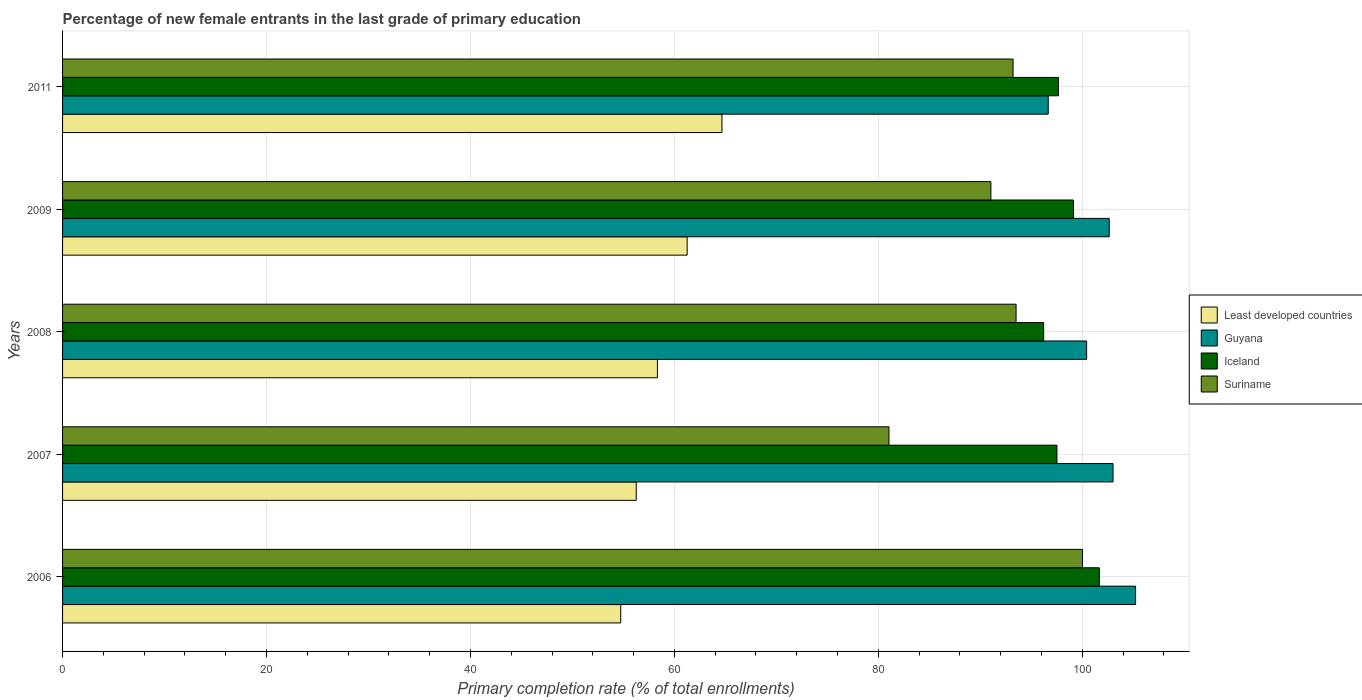How many different coloured bars are there?
Ensure brevity in your answer.  4. How many groups of bars are there?
Your response must be concise. 5. Are the number of bars on each tick of the Y-axis equal?
Make the answer very short. Yes. How many bars are there on the 2nd tick from the top?
Your answer should be compact. 4. How many bars are there on the 4th tick from the bottom?
Keep it short and to the point. 4. What is the label of the 3rd group of bars from the top?
Your response must be concise. 2008. What is the percentage of new female entrants in Suriname in 2007?
Make the answer very short. 81.04. Across all years, what is the maximum percentage of new female entrants in Suriname?
Your answer should be compact. 100.02. Across all years, what is the minimum percentage of new female entrants in Suriname?
Provide a succinct answer. 81.04. In which year was the percentage of new female entrants in Guyana maximum?
Your answer should be compact. 2006. In which year was the percentage of new female entrants in Guyana minimum?
Your response must be concise. 2011. What is the total percentage of new female entrants in Suriname in the graph?
Provide a short and direct response. 458.82. What is the difference between the percentage of new female entrants in Guyana in 2008 and that in 2009?
Your answer should be very brief. -2.21. What is the difference between the percentage of new female entrants in Suriname in 2011 and the percentage of new female entrants in Iceland in 2007?
Your answer should be compact. -4.3. What is the average percentage of new female entrants in Iceland per year?
Offer a terse response. 98.44. In the year 2007, what is the difference between the percentage of new female entrants in Iceland and percentage of new female entrants in Least developed countries?
Offer a very short reply. 41.26. In how many years, is the percentage of new female entrants in Suriname greater than 8 %?
Ensure brevity in your answer.  5. What is the ratio of the percentage of new female entrants in Iceland in 2009 to that in 2011?
Keep it short and to the point. 1.02. Is the percentage of new female entrants in Guyana in 2007 less than that in 2009?
Your answer should be compact. No. Is the difference between the percentage of new female entrants in Iceland in 2006 and 2008 greater than the difference between the percentage of new female entrants in Least developed countries in 2006 and 2008?
Give a very brief answer. Yes. What is the difference between the highest and the second highest percentage of new female entrants in Least developed countries?
Provide a short and direct response. 3.41. What is the difference between the highest and the lowest percentage of new female entrants in Guyana?
Provide a short and direct response. 8.57. Is it the case that in every year, the sum of the percentage of new female entrants in Least developed countries and percentage of new female entrants in Suriname is greater than the sum of percentage of new female entrants in Guyana and percentage of new female entrants in Iceland?
Make the answer very short. Yes. What does the 4th bar from the top in 2006 represents?
Offer a terse response. Least developed countries. What does the 3rd bar from the bottom in 2011 represents?
Provide a succinct answer. Iceland. Is it the case that in every year, the sum of the percentage of new female entrants in Least developed countries and percentage of new female entrants in Iceland is greater than the percentage of new female entrants in Guyana?
Give a very brief answer. Yes. How many bars are there?
Provide a succinct answer. 20. Are all the bars in the graph horizontal?
Your answer should be very brief. Yes. Are the values on the major ticks of X-axis written in scientific E-notation?
Offer a terse response. No. Does the graph contain any zero values?
Keep it short and to the point. No. How are the legend labels stacked?
Provide a short and direct response. Vertical. What is the title of the graph?
Your answer should be very brief. Percentage of new female entrants in the last grade of primary education. What is the label or title of the X-axis?
Give a very brief answer. Primary completion rate (% of total enrollments). What is the Primary completion rate (% of total enrollments) of Least developed countries in 2006?
Ensure brevity in your answer.  54.74. What is the Primary completion rate (% of total enrollments) in Guyana in 2006?
Your answer should be compact. 105.23. What is the Primary completion rate (% of total enrollments) of Iceland in 2006?
Offer a terse response. 101.67. What is the Primary completion rate (% of total enrollments) in Suriname in 2006?
Provide a succinct answer. 100.02. What is the Primary completion rate (% of total enrollments) in Least developed countries in 2007?
Your answer should be compact. 56.26. What is the Primary completion rate (% of total enrollments) in Guyana in 2007?
Offer a very short reply. 103.02. What is the Primary completion rate (% of total enrollments) of Iceland in 2007?
Keep it short and to the point. 97.52. What is the Primary completion rate (% of total enrollments) in Suriname in 2007?
Provide a short and direct response. 81.04. What is the Primary completion rate (% of total enrollments) of Least developed countries in 2008?
Your answer should be very brief. 58.34. What is the Primary completion rate (% of total enrollments) of Guyana in 2008?
Give a very brief answer. 100.43. What is the Primary completion rate (% of total enrollments) of Iceland in 2008?
Offer a very short reply. 96.21. What is the Primary completion rate (% of total enrollments) in Suriname in 2008?
Your response must be concise. 93.51. What is the Primary completion rate (% of total enrollments) of Least developed countries in 2009?
Provide a succinct answer. 61.25. What is the Primary completion rate (% of total enrollments) of Guyana in 2009?
Give a very brief answer. 102.64. What is the Primary completion rate (% of total enrollments) in Iceland in 2009?
Make the answer very short. 99.13. What is the Primary completion rate (% of total enrollments) of Suriname in 2009?
Provide a short and direct response. 91.04. What is the Primary completion rate (% of total enrollments) of Least developed countries in 2011?
Keep it short and to the point. 64.67. What is the Primary completion rate (% of total enrollments) in Guyana in 2011?
Provide a short and direct response. 96.66. What is the Primary completion rate (% of total enrollments) of Iceland in 2011?
Provide a succinct answer. 97.66. What is the Primary completion rate (% of total enrollments) in Suriname in 2011?
Keep it short and to the point. 93.21. Across all years, what is the maximum Primary completion rate (% of total enrollments) of Least developed countries?
Provide a short and direct response. 64.67. Across all years, what is the maximum Primary completion rate (% of total enrollments) of Guyana?
Offer a terse response. 105.23. Across all years, what is the maximum Primary completion rate (% of total enrollments) in Iceland?
Offer a terse response. 101.67. Across all years, what is the maximum Primary completion rate (% of total enrollments) in Suriname?
Provide a short and direct response. 100.02. Across all years, what is the minimum Primary completion rate (% of total enrollments) of Least developed countries?
Make the answer very short. 54.74. Across all years, what is the minimum Primary completion rate (% of total enrollments) in Guyana?
Ensure brevity in your answer.  96.66. Across all years, what is the minimum Primary completion rate (% of total enrollments) of Iceland?
Provide a short and direct response. 96.21. Across all years, what is the minimum Primary completion rate (% of total enrollments) of Suriname?
Offer a terse response. 81.04. What is the total Primary completion rate (% of total enrollments) in Least developed countries in the graph?
Provide a succinct answer. 295.25. What is the total Primary completion rate (% of total enrollments) in Guyana in the graph?
Give a very brief answer. 507.98. What is the total Primary completion rate (% of total enrollments) in Iceland in the graph?
Ensure brevity in your answer.  492.19. What is the total Primary completion rate (% of total enrollments) of Suriname in the graph?
Give a very brief answer. 458.82. What is the difference between the Primary completion rate (% of total enrollments) of Least developed countries in 2006 and that in 2007?
Your answer should be compact. -1.52. What is the difference between the Primary completion rate (% of total enrollments) of Guyana in 2006 and that in 2007?
Give a very brief answer. 2.21. What is the difference between the Primary completion rate (% of total enrollments) in Iceland in 2006 and that in 2007?
Make the answer very short. 4.16. What is the difference between the Primary completion rate (% of total enrollments) in Suriname in 2006 and that in 2007?
Your answer should be compact. 18.98. What is the difference between the Primary completion rate (% of total enrollments) of Least developed countries in 2006 and that in 2008?
Offer a terse response. -3.6. What is the difference between the Primary completion rate (% of total enrollments) in Guyana in 2006 and that in 2008?
Your response must be concise. 4.8. What is the difference between the Primary completion rate (% of total enrollments) of Iceland in 2006 and that in 2008?
Keep it short and to the point. 5.46. What is the difference between the Primary completion rate (% of total enrollments) in Suriname in 2006 and that in 2008?
Make the answer very short. 6.52. What is the difference between the Primary completion rate (% of total enrollments) of Least developed countries in 2006 and that in 2009?
Ensure brevity in your answer.  -6.51. What is the difference between the Primary completion rate (% of total enrollments) in Guyana in 2006 and that in 2009?
Ensure brevity in your answer.  2.59. What is the difference between the Primary completion rate (% of total enrollments) of Iceland in 2006 and that in 2009?
Offer a very short reply. 2.54. What is the difference between the Primary completion rate (% of total enrollments) of Suriname in 2006 and that in 2009?
Offer a very short reply. 8.98. What is the difference between the Primary completion rate (% of total enrollments) of Least developed countries in 2006 and that in 2011?
Offer a terse response. -9.93. What is the difference between the Primary completion rate (% of total enrollments) of Guyana in 2006 and that in 2011?
Your answer should be compact. 8.57. What is the difference between the Primary completion rate (% of total enrollments) of Iceland in 2006 and that in 2011?
Offer a terse response. 4.02. What is the difference between the Primary completion rate (% of total enrollments) of Suriname in 2006 and that in 2011?
Give a very brief answer. 6.81. What is the difference between the Primary completion rate (% of total enrollments) of Least developed countries in 2007 and that in 2008?
Your response must be concise. -2.08. What is the difference between the Primary completion rate (% of total enrollments) in Guyana in 2007 and that in 2008?
Keep it short and to the point. 2.59. What is the difference between the Primary completion rate (% of total enrollments) of Iceland in 2007 and that in 2008?
Keep it short and to the point. 1.3. What is the difference between the Primary completion rate (% of total enrollments) in Suriname in 2007 and that in 2008?
Your answer should be compact. -12.46. What is the difference between the Primary completion rate (% of total enrollments) of Least developed countries in 2007 and that in 2009?
Your response must be concise. -4.99. What is the difference between the Primary completion rate (% of total enrollments) of Guyana in 2007 and that in 2009?
Provide a short and direct response. 0.38. What is the difference between the Primary completion rate (% of total enrollments) in Iceland in 2007 and that in 2009?
Offer a terse response. -1.62. What is the difference between the Primary completion rate (% of total enrollments) in Suriname in 2007 and that in 2009?
Offer a very short reply. -10. What is the difference between the Primary completion rate (% of total enrollments) in Least developed countries in 2007 and that in 2011?
Provide a succinct answer. -8.41. What is the difference between the Primary completion rate (% of total enrollments) in Guyana in 2007 and that in 2011?
Keep it short and to the point. 6.36. What is the difference between the Primary completion rate (% of total enrollments) in Iceland in 2007 and that in 2011?
Your response must be concise. -0.14. What is the difference between the Primary completion rate (% of total enrollments) in Suriname in 2007 and that in 2011?
Ensure brevity in your answer.  -12.17. What is the difference between the Primary completion rate (% of total enrollments) of Least developed countries in 2008 and that in 2009?
Provide a short and direct response. -2.91. What is the difference between the Primary completion rate (% of total enrollments) in Guyana in 2008 and that in 2009?
Your response must be concise. -2.21. What is the difference between the Primary completion rate (% of total enrollments) in Iceland in 2008 and that in 2009?
Give a very brief answer. -2.92. What is the difference between the Primary completion rate (% of total enrollments) of Suriname in 2008 and that in 2009?
Offer a very short reply. 2.47. What is the difference between the Primary completion rate (% of total enrollments) in Least developed countries in 2008 and that in 2011?
Provide a succinct answer. -6.33. What is the difference between the Primary completion rate (% of total enrollments) of Guyana in 2008 and that in 2011?
Give a very brief answer. 3.77. What is the difference between the Primary completion rate (% of total enrollments) in Iceland in 2008 and that in 2011?
Provide a succinct answer. -1.44. What is the difference between the Primary completion rate (% of total enrollments) of Suriname in 2008 and that in 2011?
Make the answer very short. 0.3. What is the difference between the Primary completion rate (% of total enrollments) of Least developed countries in 2009 and that in 2011?
Offer a very short reply. -3.41. What is the difference between the Primary completion rate (% of total enrollments) in Guyana in 2009 and that in 2011?
Keep it short and to the point. 5.98. What is the difference between the Primary completion rate (% of total enrollments) in Iceland in 2009 and that in 2011?
Provide a short and direct response. 1.47. What is the difference between the Primary completion rate (% of total enrollments) in Suriname in 2009 and that in 2011?
Ensure brevity in your answer.  -2.17. What is the difference between the Primary completion rate (% of total enrollments) in Least developed countries in 2006 and the Primary completion rate (% of total enrollments) in Guyana in 2007?
Keep it short and to the point. -48.28. What is the difference between the Primary completion rate (% of total enrollments) of Least developed countries in 2006 and the Primary completion rate (% of total enrollments) of Iceland in 2007?
Ensure brevity in your answer.  -42.78. What is the difference between the Primary completion rate (% of total enrollments) of Least developed countries in 2006 and the Primary completion rate (% of total enrollments) of Suriname in 2007?
Give a very brief answer. -26.3. What is the difference between the Primary completion rate (% of total enrollments) in Guyana in 2006 and the Primary completion rate (% of total enrollments) in Iceland in 2007?
Provide a succinct answer. 7.71. What is the difference between the Primary completion rate (% of total enrollments) of Guyana in 2006 and the Primary completion rate (% of total enrollments) of Suriname in 2007?
Keep it short and to the point. 24.18. What is the difference between the Primary completion rate (% of total enrollments) of Iceland in 2006 and the Primary completion rate (% of total enrollments) of Suriname in 2007?
Ensure brevity in your answer.  20.63. What is the difference between the Primary completion rate (% of total enrollments) in Least developed countries in 2006 and the Primary completion rate (% of total enrollments) in Guyana in 2008?
Make the answer very short. -45.69. What is the difference between the Primary completion rate (% of total enrollments) in Least developed countries in 2006 and the Primary completion rate (% of total enrollments) in Iceland in 2008?
Give a very brief answer. -41.47. What is the difference between the Primary completion rate (% of total enrollments) of Least developed countries in 2006 and the Primary completion rate (% of total enrollments) of Suriname in 2008?
Your answer should be very brief. -38.77. What is the difference between the Primary completion rate (% of total enrollments) in Guyana in 2006 and the Primary completion rate (% of total enrollments) in Iceland in 2008?
Make the answer very short. 9.02. What is the difference between the Primary completion rate (% of total enrollments) in Guyana in 2006 and the Primary completion rate (% of total enrollments) in Suriname in 2008?
Offer a very short reply. 11.72. What is the difference between the Primary completion rate (% of total enrollments) of Iceland in 2006 and the Primary completion rate (% of total enrollments) of Suriname in 2008?
Make the answer very short. 8.17. What is the difference between the Primary completion rate (% of total enrollments) in Least developed countries in 2006 and the Primary completion rate (% of total enrollments) in Guyana in 2009?
Your answer should be compact. -47.9. What is the difference between the Primary completion rate (% of total enrollments) in Least developed countries in 2006 and the Primary completion rate (% of total enrollments) in Iceland in 2009?
Offer a terse response. -44.39. What is the difference between the Primary completion rate (% of total enrollments) in Least developed countries in 2006 and the Primary completion rate (% of total enrollments) in Suriname in 2009?
Make the answer very short. -36.3. What is the difference between the Primary completion rate (% of total enrollments) of Guyana in 2006 and the Primary completion rate (% of total enrollments) of Iceland in 2009?
Your answer should be very brief. 6.1. What is the difference between the Primary completion rate (% of total enrollments) of Guyana in 2006 and the Primary completion rate (% of total enrollments) of Suriname in 2009?
Your response must be concise. 14.19. What is the difference between the Primary completion rate (% of total enrollments) in Iceland in 2006 and the Primary completion rate (% of total enrollments) in Suriname in 2009?
Offer a very short reply. 10.63. What is the difference between the Primary completion rate (% of total enrollments) in Least developed countries in 2006 and the Primary completion rate (% of total enrollments) in Guyana in 2011?
Your answer should be compact. -41.92. What is the difference between the Primary completion rate (% of total enrollments) in Least developed countries in 2006 and the Primary completion rate (% of total enrollments) in Iceland in 2011?
Your response must be concise. -42.92. What is the difference between the Primary completion rate (% of total enrollments) in Least developed countries in 2006 and the Primary completion rate (% of total enrollments) in Suriname in 2011?
Offer a very short reply. -38.47. What is the difference between the Primary completion rate (% of total enrollments) of Guyana in 2006 and the Primary completion rate (% of total enrollments) of Iceland in 2011?
Your response must be concise. 7.57. What is the difference between the Primary completion rate (% of total enrollments) in Guyana in 2006 and the Primary completion rate (% of total enrollments) in Suriname in 2011?
Make the answer very short. 12.02. What is the difference between the Primary completion rate (% of total enrollments) in Iceland in 2006 and the Primary completion rate (% of total enrollments) in Suriname in 2011?
Make the answer very short. 8.46. What is the difference between the Primary completion rate (% of total enrollments) in Least developed countries in 2007 and the Primary completion rate (% of total enrollments) in Guyana in 2008?
Your answer should be very brief. -44.17. What is the difference between the Primary completion rate (% of total enrollments) of Least developed countries in 2007 and the Primary completion rate (% of total enrollments) of Iceland in 2008?
Keep it short and to the point. -39.95. What is the difference between the Primary completion rate (% of total enrollments) in Least developed countries in 2007 and the Primary completion rate (% of total enrollments) in Suriname in 2008?
Your response must be concise. -37.25. What is the difference between the Primary completion rate (% of total enrollments) of Guyana in 2007 and the Primary completion rate (% of total enrollments) of Iceland in 2008?
Make the answer very short. 6.81. What is the difference between the Primary completion rate (% of total enrollments) of Guyana in 2007 and the Primary completion rate (% of total enrollments) of Suriname in 2008?
Offer a very short reply. 9.51. What is the difference between the Primary completion rate (% of total enrollments) in Iceland in 2007 and the Primary completion rate (% of total enrollments) in Suriname in 2008?
Provide a short and direct response. 4.01. What is the difference between the Primary completion rate (% of total enrollments) in Least developed countries in 2007 and the Primary completion rate (% of total enrollments) in Guyana in 2009?
Make the answer very short. -46.38. What is the difference between the Primary completion rate (% of total enrollments) in Least developed countries in 2007 and the Primary completion rate (% of total enrollments) in Iceland in 2009?
Your answer should be very brief. -42.87. What is the difference between the Primary completion rate (% of total enrollments) in Least developed countries in 2007 and the Primary completion rate (% of total enrollments) in Suriname in 2009?
Keep it short and to the point. -34.78. What is the difference between the Primary completion rate (% of total enrollments) of Guyana in 2007 and the Primary completion rate (% of total enrollments) of Iceland in 2009?
Your answer should be very brief. 3.89. What is the difference between the Primary completion rate (% of total enrollments) in Guyana in 2007 and the Primary completion rate (% of total enrollments) in Suriname in 2009?
Ensure brevity in your answer.  11.98. What is the difference between the Primary completion rate (% of total enrollments) of Iceland in 2007 and the Primary completion rate (% of total enrollments) of Suriname in 2009?
Make the answer very short. 6.48. What is the difference between the Primary completion rate (% of total enrollments) of Least developed countries in 2007 and the Primary completion rate (% of total enrollments) of Guyana in 2011?
Offer a terse response. -40.4. What is the difference between the Primary completion rate (% of total enrollments) in Least developed countries in 2007 and the Primary completion rate (% of total enrollments) in Iceland in 2011?
Offer a very short reply. -41.4. What is the difference between the Primary completion rate (% of total enrollments) of Least developed countries in 2007 and the Primary completion rate (% of total enrollments) of Suriname in 2011?
Give a very brief answer. -36.95. What is the difference between the Primary completion rate (% of total enrollments) in Guyana in 2007 and the Primary completion rate (% of total enrollments) in Iceland in 2011?
Your answer should be very brief. 5.36. What is the difference between the Primary completion rate (% of total enrollments) in Guyana in 2007 and the Primary completion rate (% of total enrollments) in Suriname in 2011?
Your answer should be compact. 9.81. What is the difference between the Primary completion rate (% of total enrollments) of Iceland in 2007 and the Primary completion rate (% of total enrollments) of Suriname in 2011?
Provide a short and direct response. 4.3. What is the difference between the Primary completion rate (% of total enrollments) of Least developed countries in 2008 and the Primary completion rate (% of total enrollments) of Guyana in 2009?
Offer a very short reply. -44.3. What is the difference between the Primary completion rate (% of total enrollments) of Least developed countries in 2008 and the Primary completion rate (% of total enrollments) of Iceland in 2009?
Ensure brevity in your answer.  -40.79. What is the difference between the Primary completion rate (% of total enrollments) in Least developed countries in 2008 and the Primary completion rate (% of total enrollments) in Suriname in 2009?
Provide a short and direct response. -32.7. What is the difference between the Primary completion rate (% of total enrollments) in Guyana in 2008 and the Primary completion rate (% of total enrollments) in Iceland in 2009?
Offer a very short reply. 1.29. What is the difference between the Primary completion rate (% of total enrollments) of Guyana in 2008 and the Primary completion rate (% of total enrollments) of Suriname in 2009?
Offer a very short reply. 9.39. What is the difference between the Primary completion rate (% of total enrollments) of Iceland in 2008 and the Primary completion rate (% of total enrollments) of Suriname in 2009?
Offer a very short reply. 5.17. What is the difference between the Primary completion rate (% of total enrollments) of Least developed countries in 2008 and the Primary completion rate (% of total enrollments) of Guyana in 2011?
Make the answer very short. -38.32. What is the difference between the Primary completion rate (% of total enrollments) in Least developed countries in 2008 and the Primary completion rate (% of total enrollments) in Iceland in 2011?
Provide a succinct answer. -39.32. What is the difference between the Primary completion rate (% of total enrollments) in Least developed countries in 2008 and the Primary completion rate (% of total enrollments) in Suriname in 2011?
Offer a terse response. -34.87. What is the difference between the Primary completion rate (% of total enrollments) of Guyana in 2008 and the Primary completion rate (% of total enrollments) of Iceland in 2011?
Offer a very short reply. 2.77. What is the difference between the Primary completion rate (% of total enrollments) of Guyana in 2008 and the Primary completion rate (% of total enrollments) of Suriname in 2011?
Make the answer very short. 7.21. What is the difference between the Primary completion rate (% of total enrollments) in Iceland in 2008 and the Primary completion rate (% of total enrollments) in Suriname in 2011?
Give a very brief answer. 3. What is the difference between the Primary completion rate (% of total enrollments) of Least developed countries in 2009 and the Primary completion rate (% of total enrollments) of Guyana in 2011?
Offer a terse response. -35.41. What is the difference between the Primary completion rate (% of total enrollments) in Least developed countries in 2009 and the Primary completion rate (% of total enrollments) in Iceland in 2011?
Give a very brief answer. -36.41. What is the difference between the Primary completion rate (% of total enrollments) of Least developed countries in 2009 and the Primary completion rate (% of total enrollments) of Suriname in 2011?
Keep it short and to the point. -31.96. What is the difference between the Primary completion rate (% of total enrollments) in Guyana in 2009 and the Primary completion rate (% of total enrollments) in Iceland in 2011?
Keep it short and to the point. 4.98. What is the difference between the Primary completion rate (% of total enrollments) of Guyana in 2009 and the Primary completion rate (% of total enrollments) of Suriname in 2011?
Provide a short and direct response. 9.43. What is the difference between the Primary completion rate (% of total enrollments) in Iceland in 2009 and the Primary completion rate (% of total enrollments) in Suriname in 2011?
Give a very brief answer. 5.92. What is the average Primary completion rate (% of total enrollments) in Least developed countries per year?
Ensure brevity in your answer.  59.05. What is the average Primary completion rate (% of total enrollments) in Guyana per year?
Ensure brevity in your answer.  101.6. What is the average Primary completion rate (% of total enrollments) of Iceland per year?
Provide a short and direct response. 98.44. What is the average Primary completion rate (% of total enrollments) in Suriname per year?
Keep it short and to the point. 91.76. In the year 2006, what is the difference between the Primary completion rate (% of total enrollments) of Least developed countries and Primary completion rate (% of total enrollments) of Guyana?
Provide a short and direct response. -50.49. In the year 2006, what is the difference between the Primary completion rate (% of total enrollments) in Least developed countries and Primary completion rate (% of total enrollments) in Iceland?
Make the answer very short. -46.93. In the year 2006, what is the difference between the Primary completion rate (% of total enrollments) of Least developed countries and Primary completion rate (% of total enrollments) of Suriname?
Make the answer very short. -45.28. In the year 2006, what is the difference between the Primary completion rate (% of total enrollments) of Guyana and Primary completion rate (% of total enrollments) of Iceland?
Your answer should be compact. 3.55. In the year 2006, what is the difference between the Primary completion rate (% of total enrollments) of Guyana and Primary completion rate (% of total enrollments) of Suriname?
Offer a terse response. 5.21. In the year 2006, what is the difference between the Primary completion rate (% of total enrollments) of Iceland and Primary completion rate (% of total enrollments) of Suriname?
Provide a succinct answer. 1.65. In the year 2007, what is the difference between the Primary completion rate (% of total enrollments) in Least developed countries and Primary completion rate (% of total enrollments) in Guyana?
Give a very brief answer. -46.76. In the year 2007, what is the difference between the Primary completion rate (% of total enrollments) of Least developed countries and Primary completion rate (% of total enrollments) of Iceland?
Ensure brevity in your answer.  -41.26. In the year 2007, what is the difference between the Primary completion rate (% of total enrollments) of Least developed countries and Primary completion rate (% of total enrollments) of Suriname?
Give a very brief answer. -24.78. In the year 2007, what is the difference between the Primary completion rate (% of total enrollments) in Guyana and Primary completion rate (% of total enrollments) in Iceland?
Make the answer very short. 5.5. In the year 2007, what is the difference between the Primary completion rate (% of total enrollments) of Guyana and Primary completion rate (% of total enrollments) of Suriname?
Ensure brevity in your answer.  21.98. In the year 2007, what is the difference between the Primary completion rate (% of total enrollments) in Iceland and Primary completion rate (% of total enrollments) in Suriname?
Keep it short and to the point. 16.47. In the year 2008, what is the difference between the Primary completion rate (% of total enrollments) in Least developed countries and Primary completion rate (% of total enrollments) in Guyana?
Your answer should be very brief. -42.09. In the year 2008, what is the difference between the Primary completion rate (% of total enrollments) in Least developed countries and Primary completion rate (% of total enrollments) in Iceland?
Offer a terse response. -37.88. In the year 2008, what is the difference between the Primary completion rate (% of total enrollments) of Least developed countries and Primary completion rate (% of total enrollments) of Suriname?
Provide a succinct answer. -35.17. In the year 2008, what is the difference between the Primary completion rate (% of total enrollments) in Guyana and Primary completion rate (% of total enrollments) in Iceland?
Your answer should be compact. 4.21. In the year 2008, what is the difference between the Primary completion rate (% of total enrollments) in Guyana and Primary completion rate (% of total enrollments) in Suriname?
Your answer should be compact. 6.92. In the year 2008, what is the difference between the Primary completion rate (% of total enrollments) in Iceland and Primary completion rate (% of total enrollments) in Suriname?
Your response must be concise. 2.71. In the year 2009, what is the difference between the Primary completion rate (% of total enrollments) in Least developed countries and Primary completion rate (% of total enrollments) in Guyana?
Give a very brief answer. -41.39. In the year 2009, what is the difference between the Primary completion rate (% of total enrollments) in Least developed countries and Primary completion rate (% of total enrollments) in Iceland?
Ensure brevity in your answer.  -37.88. In the year 2009, what is the difference between the Primary completion rate (% of total enrollments) of Least developed countries and Primary completion rate (% of total enrollments) of Suriname?
Give a very brief answer. -29.79. In the year 2009, what is the difference between the Primary completion rate (% of total enrollments) in Guyana and Primary completion rate (% of total enrollments) in Iceland?
Give a very brief answer. 3.51. In the year 2009, what is the difference between the Primary completion rate (% of total enrollments) in Guyana and Primary completion rate (% of total enrollments) in Suriname?
Offer a very short reply. 11.6. In the year 2009, what is the difference between the Primary completion rate (% of total enrollments) of Iceland and Primary completion rate (% of total enrollments) of Suriname?
Make the answer very short. 8.09. In the year 2011, what is the difference between the Primary completion rate (% of total enrollments) in Least developed countries and Primary completion rate (% of total enrollments) in Guyana?
Ensure brevity in your answer.  -32. In the year 2011, what is the difference between the Primary completion rate (% of total enrollments) of Least developed countries and Primary completion rate (% of total enrollments) of Iceland?
Provide a short and direct response. -32.99. In the year 2011, what is the difference between the Primary completion rate (% of total enrollments) of Least developed countries and Primary completion rate (% of total enrollments) of Suriname?
Your response must be concise. -28.55. In the year 2011, what is the difference between the Primary completion rate (% of total enrollments) in Guyana and Primary completion rate (% of total enrollments) in Iceland?
Provide a short and direct response. -1. In the year 2011, what is the difference between the Primary completion rate (% of total enrollments) of Guyana and Primary completion rate (% of total enrollments) of Suriname?
Your response must be concise. 3.45. In the year 2011, what is the difference between the Primary completion rate (% of total enrollments) of Iceland and Primary completion rate (% of total enrollments) of Suriname?
Give a very brief answer. 4.45. What is the ratio of the Primary completion rate (% of total enrollments) in Guyana in 2006 to that in 2007?
Offer a terse response. 1.02. What is the ratio of the Primary completion rate (% of total enrollments) of Iceland in 2006 to that in 2007?
Make the answer very short. 1.04. What is the ratio of the Primary completion rate (% of total enrollments) of Suriname in 2006 to that in 2007?
Make the answer very short. 1.23. What is the ratio of the Primary completion rate (% of total enrollments) in Least developed countries in 2006 to that in 2008?
Make the answer very short. 0.94. What is the ratio of the Primary completion rate (% of total enrollments) in Guyana in 2006 to that in 2008?
Keep it short and to the point. 1.05. What is the ratio of the Primary completion rate (% of total enrollments) in Iceland in 2006 to that in 2008?
Keep it short and to the point. 1.06. What is the ratio of the Primary completion rate (% of total enrollments) of Suriname in 2006 to that in 2008?
Keep it short and to the point. 1.07. What is the ratio of the Primary completion rate (% of total enrollments) in Least developed countries in 2006 to that in 2009?
Keep it short and to the point. 0.89. What is the ratio of the Primary completion rate (% of total enrollments) of Guyana in 2006 to that in 2009?
Provide a succinct answer. 1.03. What is the ratio of the Primary completion rate (% of total enrollments) in Iceland in 2006 to that in 2009?
Provide a short and direct response. 1.03. What is the ratio of the Primary completion rate (% of total enrollments) in Suriname in 2006 to that in 2009?
Your response must be concise. 1.1. What is the ratio of the Primary completion rate (% of total enrollments) in Least developed countries in 2006 to that in 2011?
Provide a short and direct response. 0.85. What is the ratio of the Primary completion rate (% of total enrollments) of Guyana in 2006 to that in 2011?
Keep it short and to the point. 1.09. What is the ratio of the Primary completion rate (% of total enrollments) in Iceland in 2006 to that in 2011?
Offer a terse response. 1.04. What is the ratio of the Primary completion rate (% of total enrollments) of Suriname in 2006 to that in 2011?
Provide a short and direct response. 1.07. What is the ratio of the Primary completion rate (% of total enrollments) of Least developed countries in 2007 to that in 2008?
Keep it short and to the point. 0.96. What is the ratio of the Primary completion rate (% of total enrollments) in Guyana in 2007 to that in 2008?
Offer a very short reply. 1.03. What is the ratio of the Primary completion rate (% of total enrollments) of Iceland in 2007 to that in 2008?
Your answer should be very brief. 1.01. What is the ratio of the Primary completion rate (% of total enrollments) of Suriname in 2007 to that in 2008?
Provide a short and direct response. 0.87. What is the ratio of the Primary completion rate (% of total enrollments) of Least developed countries in 2007 to that in 2009?
Provide a short and direct response. 0.92. What is the ratio of the Primary completion rate (% of total enrollments) of Iceland in 2007 to that in 2009?
Ensure brevity in your answer.  0.98. What is the ratio of the Primary completion rate (% of total enrollments) in Suriname in 2007 to that in 2009?
Give a very brief answer. 0.89. What is the ratio of the Primary completion rate (% of total enrollments) of Least developed countries in 2007 to that in 2011?
Give a very brief answer. 0.87. What is the ratio of the Primary completion rate (% of total enrollments) of Guyana in 2007 to that in 2011?
Make the answer very short. 1.07. What is the ratio of the Primary completion rate (% of total enrollments) in Iceland in 2007 to that in 2011?
Your answer should be very brief. 1. What is the ratio of the Primary completion rate (% of total enrollments) in Suriname in 2007 to that in 2011?
Your answer should be very brief. 0.87. What is the ratio of the Primary completion rate (% of total enrollments) of Least developed countries in 2008 to that in 2009?
Ensure brevity in your answer.  0.95. What is the ratio of the Primary completion rate (% of total enrollments) of Guyana in 2008 to that in 2009?
Your response must be concise. 0.98. What is the ratio of the Primary completion rate (% of total enrollments) in Iceland in 2008 to that in 2009?
Give a very brief answer. 0.97. What is the ratio of the Primary completion rate (% of total enrollments) of Suriname in 2008 to that in 2009?
Provide a succinct answer. 1.03. What is the ratio of the Primary completion rate (% of total enrollments) in Least developed countries in 2008 to that in 2011?
Offer a very short reply. 0.9. What is the ratio of the Primary completion rate (% of total enrollments) of Guyana in 2008 to that in 2011?
Offer a terse response. 1.04. What is the ratio of the Primary completion rate (% of total enrollments) of Iceland in 2008 to that in 2011?
Ensure brevity in your answer.  0.99. What is the ratio of the Primary completion rate (% of total enrollments) of Suriname in 2008 to that in 2011?
Offer a terse response. 1. What is the ratio of the Primary completion rate (% of total enrollments) of Least developed countries in 2009 to that in 2011?
Make the answer very short. 0.95. What is the ratio of the Primary completion rate (% of total enrollments) of Guyana in 2009 to that in 2011?
Your response must be concise. 1.06. What is the ratio of the Primary completion rate (% of total enrollments) of Iceland in 2009 to that in 2011?
Offer a terse response. 1.02. What is the ratio of the Primary completion rate (% of total enrollments) of Suriname in 2009 to that in 2011?
Provide a short and direct response. 0.98. What is the difference between the highest and the second highest Primary completion rate (% of total enrollments) in Least developed countries?
Offer a very short reply. 3.41. What is the difference between the highest and the second highest Primary completion rate (% of total enrollments) in Guyana?
Offer a terse response. 2.21. What is the difference between the highest and the second highest Primary completion rate (% of total enrollments) of Iceland?
Ensure brevity in your answer.  2.54. What is the difference between the highest and the second highest Primary completion rate (% of total enrollments) of Suriname?
Provide a succinct answer. 6.52. What is the difference between the highest and the lowest Primary completion rate (% of total enrollments) of Least developed countries?
Provide a succinct answer. 9.93. What is the difference between the highest and the lowest Primary completion rate (% of total enrollments) of Guyana?
Ensure brevity in your answer.  8.57. What is the difference between the highest and the lowest Primary completion rate (% of total enrollments) in Iceland?
Offer a terse response. 5.46. What is the difference between the highest and the lowest Primary completion rate (% of total enrollments) of Suriname?
Make the answer very short. 18.98. 